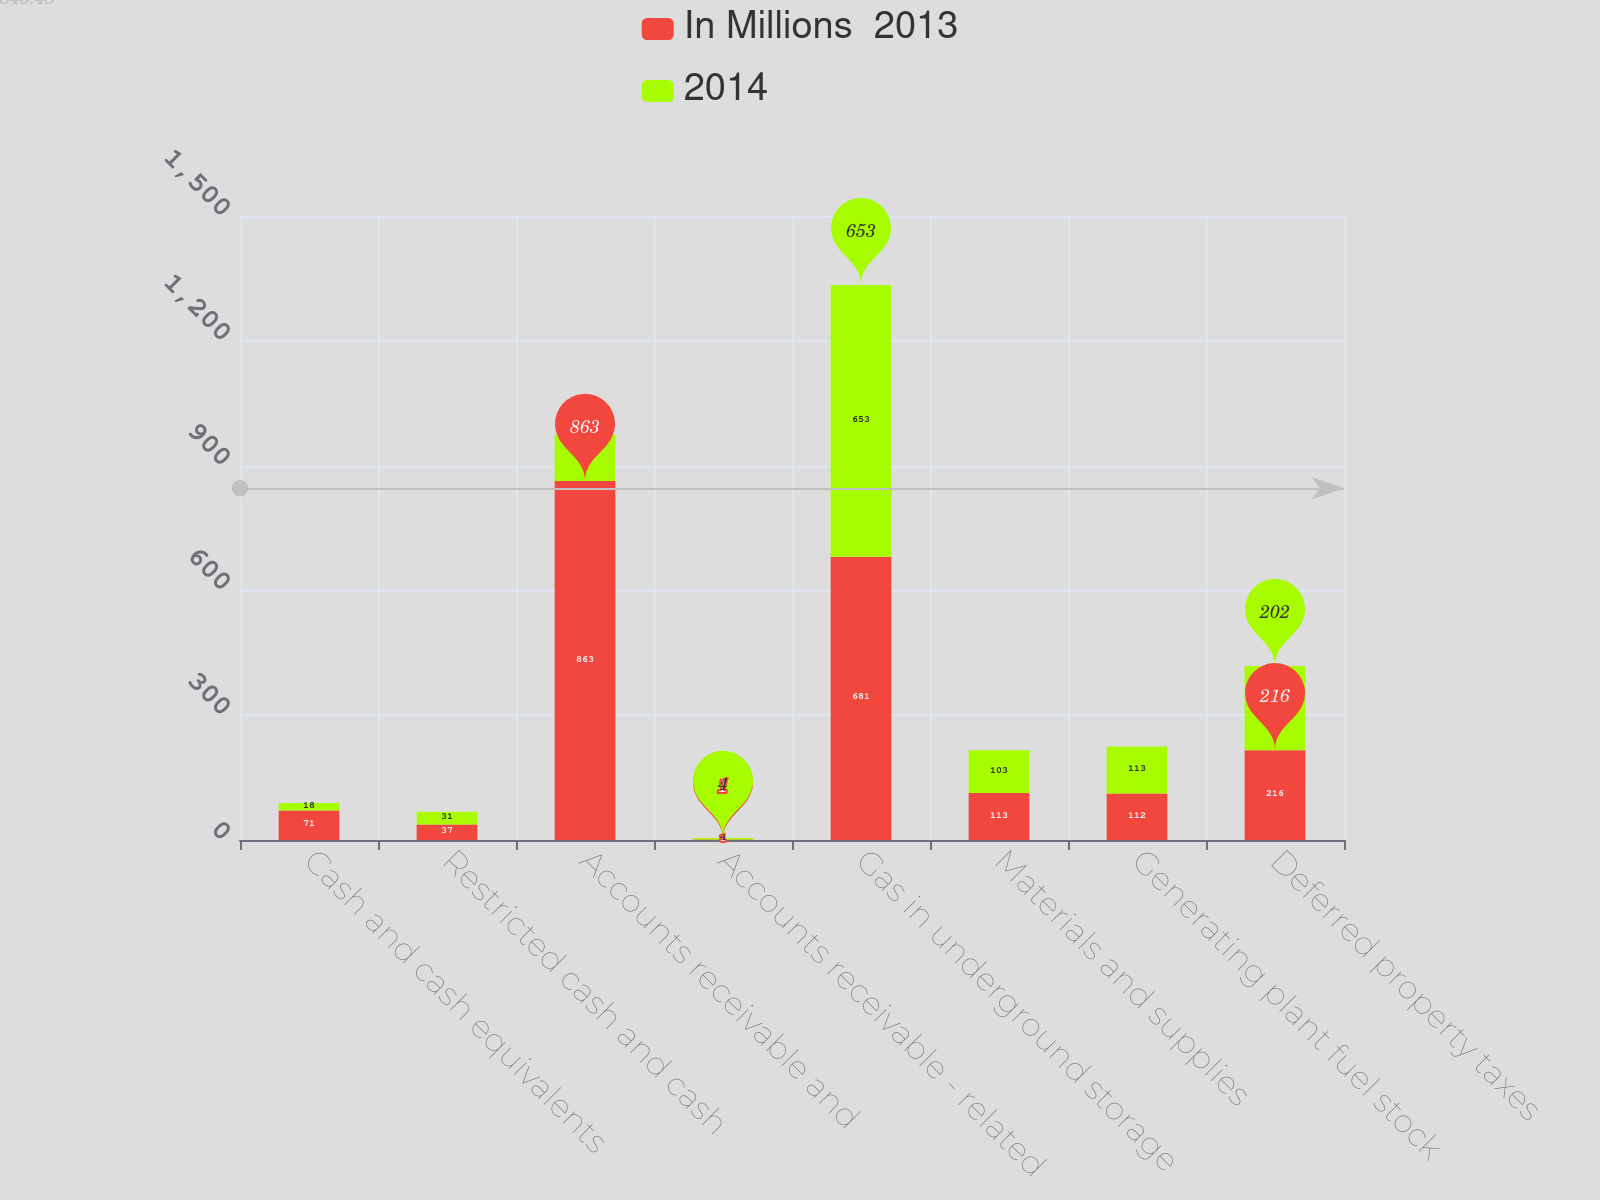Convert chart. <chart><loc_0><loc_0><loc_500><loc_500><stacked_bar_chart><ecel><fcel>Cash and cash equivalents<fcel>Restricted cash and cash<fcel>Accounts receivable and<fcel>Accounts receivable - related<fcel>Gas in underground storage<fcel>Materials and supplies<fcel>Generating plant fuel stock<fcel>Deferred property taxes<nl><fcel>In Millions  2013<fcel>71<fcel>37<fcel>863<fcel>1<fcel>681<fcel>113<fcel>112<fcel>216<nl><fcel>2014<fcel>18<fcel>31<fcel>112<fcel>4<fcel>653<fcel>103<fcel>113<fcel>202<nl></chart> 